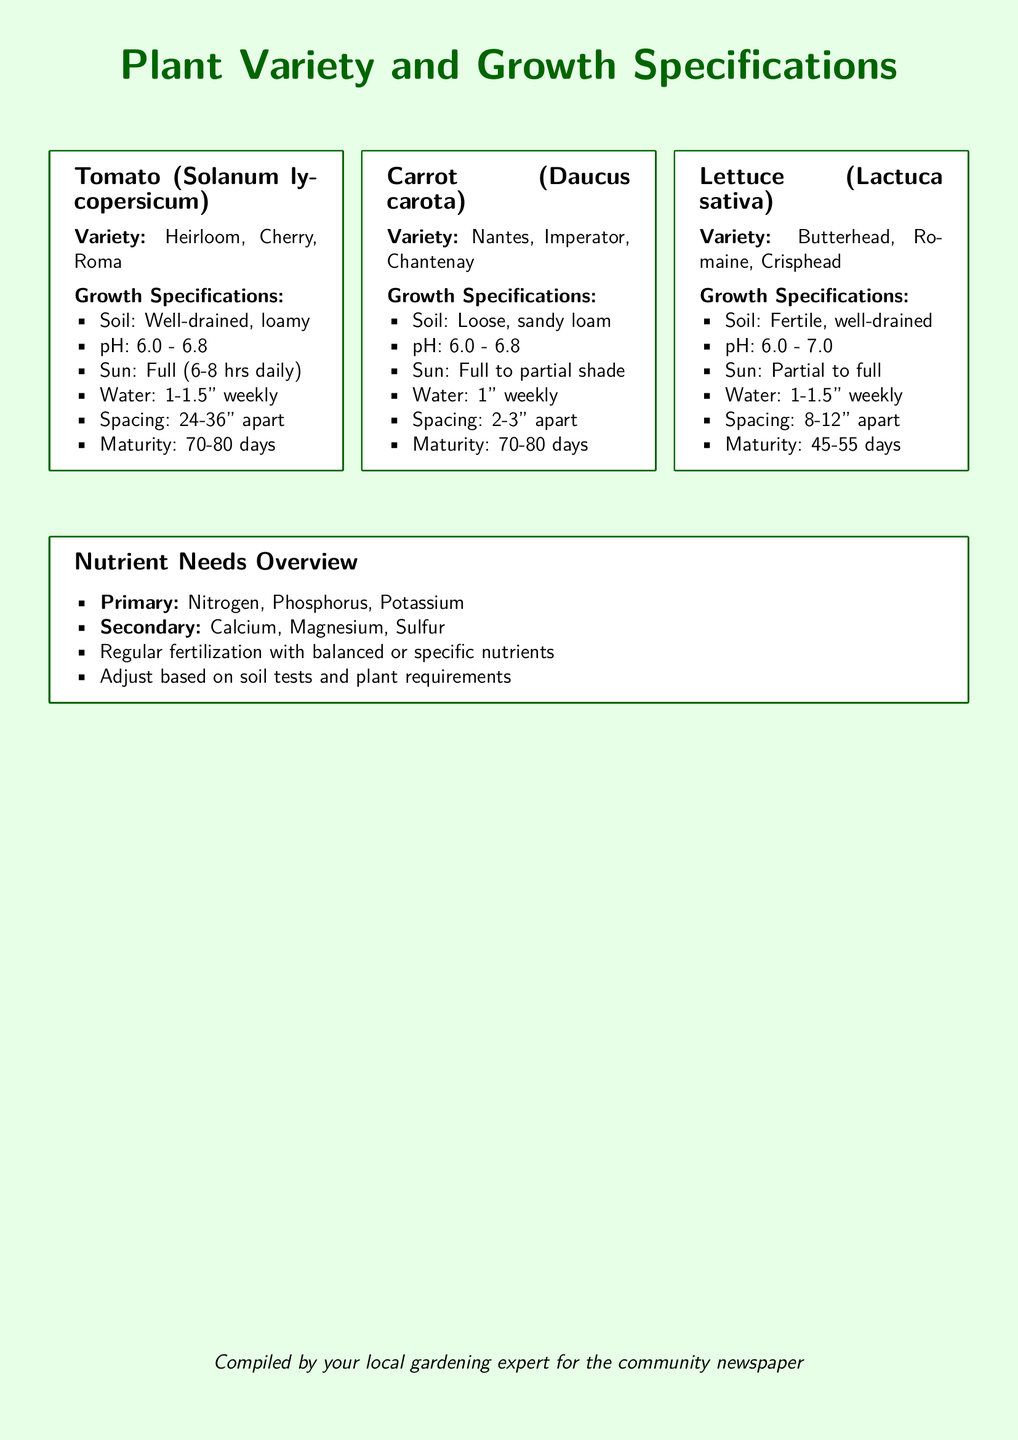What is the variety of Tomato? The document specifies three varieties of Tomato: Heirloom, Cherry, Roma.
Answer: Heirloom, Cherry, Roma What is the pH range for Carrots? The pH range for Carrots is stated in the specifications as 6.0 - 6.8.
Answer: 6.0 - 6.8 What is the maturity time for Lettuce? The maturity time indicated for Lettuce ranges from 45 to 55 days.
Answer: 45-55 days How much water do Tomatoes need weekly? The document mentions that Tomatoes require 1 to 1.5 inches of water weekly.
Answer: 1-1.5" What soil type is recommended for Carrots? It is specified that Carrots prefer loose, sandy loam soil.
Answer: Loose, sandy loam What are the primary nutrients listed? The overview highlights Nitrogen, Phosphorus, and Potassium as primary nutrients needed.
Answer: Nitrogen, Phosphorus, Potassium Which plant variety requires the least amount of maturation time? The document indicates that Lettuce matures faster than the other varieties.
Answer: Lettuce Why is soil testing important according to the document? Soil testing allows for adjustments based on nutrient needs and plant requirements.
Answer: Adjustments based on soil tests What aspect of gardening does this document primarily focus on? The document focuses on plant variety and growth specifications along with nutrient needs.
Answer: Plant variety and growth specifications What color is used for the background of the document? The background color is specified as light green.
Answer: Light green 